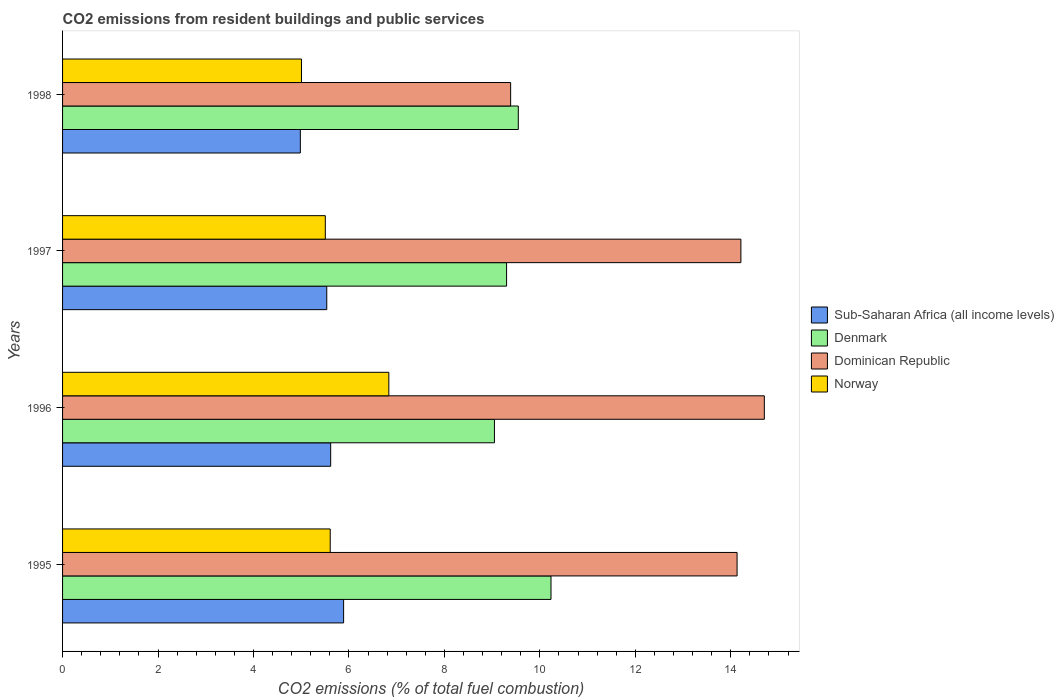How many bars are there on the 1st tick from the top?
Offer a terse response. 4. What is the label of the 4th group of bars from the top?
Keep it short and to the point. 1995. What is the total CO2 emitted in Dominican Republic in 1998?
Your response must be concise. 9.39. Across all years, what is the maximum total CO2 emitted in Dominican Republic?
Your answer should be very brief. 14.7. Across all years, what is the minimum total CO2 emitted in Dominican Republic?
Keep it short and to the point. 9.39. What is the total total CO2 emitted in Sub-Saharan Africa (all income levels) in the graph?
Your answer should be very brief. 22.02. What is the difference between the total CO2 emitted in Sub-Saharan Africa (all income levels) in 1996 and that in 1997?
Make the answer very short. 0.08. What is the difference between the total CO2 emitted in Dominican Republic in 1996 and the total CO2 emitted in Denmark in 1997?
Make the answer very short. 5.4. What is the average total CO2 emitted in Sub-Saharan Africa (all income levels) per year?
Ensure brevity in your answer.  5.51. In the year 1996, what is the difference between the total CO2 emitted in Sub-Saharan Africa (all income levels) and total CO2 emitted in Denmark?
Your answer should be compact. -3.43. What is the ratio of the total CO2 emitted in Sub-Saharan Africa (all income levels) in 1996 to that in 1998?
Keep it short and to the point. 1.13. What is the difference between the highest and the second highest total CO2 emitted in Dominican Republic?
Give a very brief answer. 0.49. What is the difference between the highest and the lowest total CO2 emitted in Dominican Republic?
Your answer should be compact. 5.32. In how many years, is the total CO2 emitted in Norway greater than the average total CO2 emitted in Norway taken over all years?
Your response must be concise. 1. Is the sum of the total CO2 emitted in Dominican Republic in 1995 and 1998 greater than the maximum total CO2 emitted in Denmark across all years?
Make the answer very short. Yes. Is it the case that in every year, the sum of the total CO2 emitted in Dominican Republic and total CO2 emitted in Sub-Saharan Africa (all income levels) is greater than the sum of total CO2 emitted in Norway and total CO2 emitted in Denmark?
Provide a succinct answer. No. What does the 2nd bar from the top in 1997 represents?
Offer a terse response. Dominican Republic. What does the 3rd bar from the bottom in 1997 represents?
Ensure brevity in your answer.  Dominican Republic. How many bars are there?
Offer a terse response. 16. How many years are there in the graph?
Ensure brevity in your answer.  4. Does the graph contain any zero values?
Your response must be concise. No. How many legend labels are there?
Provide a short and direct response. 4. How are the legend labels stacked?
Offer a terse response. Vertical. What is the title of the graph?
Offer a very short reply. CO2 emissions from resident buildings and public services. What is the label or title of the X-axis?
Give a very brief answer. CO2 emissions (% of total fuel combustion). What is the CO2 emissions (% of total fuel combustion) of Sub-Saharan Africa (all income levels) in 1995?
Ensure brevity in your answer.  5.89. What is the CO2 emissions (% of total fuel combustion) in Denmark in 1995?
Provide a succinct answer. 10.23. What is the CO2 emissions (% of total fuel combustion) in Dominican Republic in 1995?
Give a very brief answer. 14.13. What is the CO2 emissions (% of total fuel combustion) in Norway in 1995?
Make the answer very short. 5.61. What is the CO2 emissions (% of total fuel combustion) of Sub-Saharan Africa (all income levels) in 1996?
Offer a terse response. 5.62. What is the CO2 emissions (% of total fuel combustion) of Denmark in 1996?
Your answer should be very brief. 9.05. What is the CO2 emissions (% of total fuel combustion) in Dominican Republic in 1996?
Keep it short and to the point. 14.7. What is the CO2 emissions (% of total fuel combustion) of Norway in 1996?
Your answer should be very brief. 6.84. What is the CO2 emissions (% of total fuel combustion) in Sub-Saharan Africa (all income levels) in 1997?
Provide a short and direct response. 5.54. What is the CO2 emissions (% of total fuel combustion) of Denmark in 1997?
Provide a short and direct response. 9.3. What is the CO2 emissions (% of total fuel combustion) in Dominican Republic in 1997?
Provide a short and direct response. 14.21. What is the CO2 emissions (% of total fuel combustion) of Norway in 1997?
Provide a short and direct response. 5.51. What is the CO2 emissions (% of total fuel combustion) in Sub-Saharan Africa (all income levels) in 1998?
Ensure brevity in your answer.  4.98. What is the CO2 emissions (% of total fuel combustion) of Denmark in 1998?
Provide a succinct answer. 9.55. What is the CO2 emissions (% of total fuel combustion) of Dominican Republic in 1998?
Your answer should be very brief. 9.39. What is the CO2 emissions (% of total fuel combustion) in Norway in 1998?
Keep it short and to the point. 5.01. Across all years, what is the maximum CO2 emissions (% of total fuel combustion) of Sub-Saharan Africa (all income levels)?
Offer a terse response. 5.89. Across all years, what is the maximum CO2 emissions (% of total fuel combustion) in Denmark?
Ensure brevity in your answer.  10.23. Across all years, what is the maximum CO2 emissions (% of total fuel combustion) of Dominican Republic?
Provide a short and direct response. 14.7. Across all years, what is the maximum CO2 emissions (% of total fuel combustion) of Norway?
Keep it short and to the point. 6.84. Across all years, what is the minimum CO2 emissions (% of total fuel combustion) of Sub-Saharan Africa (all income levels)?
Give a very brief answer. 4.98. Across all years, what is the minimum CO2 emissions (% of total fuel combustion) of Denmark?
Give a very brief answer. 9.05. Across all years, what is the minimum CO2 emissions (% of total fuel combustion) of Dominican Republic?
Your response must be concise. 9.39. Across all years, what is the minimum CO2 emissions (% of total fuel combustion) of Norway?
Your response must be concise. 5.01. What is the total CO2 emissions (% of total fuel combustion) of Sub-Saharan Africa (all income levels) in the graph?
Keep it short and to the point. 22.02. What is the total CO2 emissions (% of total fuel combustion) of Denmark in the graph?
Provide a short and direct response. 38.13. What is the total CO2 emissions (% of total fuel combustion) of Dominican Republic in the graph?
Make the answer very short. 52.44. What is the total CO2 emissions (% of total fuel combustion) in Norway in the graph?
Offer a terse response. 22.95. What is the difference between the CO2 emissions (% of total fuel combustion) of Sub-Saharan Africa (all income levels) in 1995 and that in 1996?
Give a very brief answer. 0.27. What is the difference between the CO2 emissions (% of total fuel combustion) of Denmark in 1995 and that in 1996?
Offer a very short reply. 1.19. What is the difference between the CO2 emissions (% of total fuel combustion) of Dominican Republic in 1995 and that in 1996?
Offer a very short reply. -0.57. What is the difference between the CO2 emissions (% of total fuel combustion) in Norway in 1995 and that in 1996?
Ensure brevity in your answer.  -1.23. What is the difference between the CO2 emissions (% of total fuel combustion) of Sub-Saharan Africa (all income levels) in 1995 and that in 1997?
Give a very brief answer. 0.35. What is the difference between the CO2 emissions (% of total fuel combustion) in Denmark in 1995 and that in 1997?
Provide a short and direct response. 0.93. What is the difference between the CO2 emissions (% of total fuel combustion) in Dominican Republic in 1995 and that in 1997?
Provide a short and direct response. -0.08. What is the difference between the CO2 emissions (% of total fuel combustion) of Norway in 1995 and that in 1997?
Your answer should be compact. 0.1. What is the difference between the CO2 emissions (% of total fuel combustion) of Sub-Saharan Africa (all income levels) in 1995 and that in 1998?
Offer a very short reply. 0.91. What is the difference between the CO2 emissions (% of total fuel combustion) in Denmark in 1995 and that in 1998?
Your answer should be compact. 0.69. What is the difference between the CO2 emissions (% of total fuel combustion) of Dominican Republic in 1995 and that in 1998?
Offer a terse response. 4.74. What is the difference between the CO2 emissions (% of total fuel combustion) of Norway in 1995 and that in 1998?
Provide a succinct answer. 0.6. What is the difference between the CO2 emissions (% of total fuel combustion) in Sub-Saharan Africa (all income levels) in 1996 and that in 1997?
Offer a terse response. 0.08. What is the difference between the CO2 emissions (% of total fuel combustion) in Denmark in 1996 and that in 1997?
Keep it short and to the point. -0.25. What is the difference between the CO2 emissions (% of total fuel combustion) in Dominican Republic in 1996 and that in 1997?
Your answer should be very brief. 0.49. What is the difference between the CO2 emissions (% of total fuel combustion) in Norway in 1996 and that in 1997?
Your answer should be very brief. 1.33. What is the difference between the CO2 emissions (% of total fuel combustion) in Sub-Saharan Africa (all income levels) in 1996 and that in 1998?
Make the answer very short. 0.64. What is the difference between the CO2 emissions (% of total fuel combustion) in Denmark in 1996 and that in 1998?
Offer a very short reply. -0.5. What is the difference between the CO2 emissions (% of total fuel combustion) in Dominican Republic in 1996 and that in 1998?
Ensure brevity in your answer.  5.32. What is the difference between the CO2 emissions (% of total fuel combustion) in Norway in 1996 and that in 1998?
Provide a short and direct response. 1.83. What is the difference between the CO2 emissions (% of total fuel combustion) in Sub-Saharan Africa (all income levels) in 1997 and that in 1998?
Offer a very short reply. 0.55. What is the difference between the CO2 emissions (% of total fuel combustion) in Denmark in 1997 and that in 1998?
Give a very brief answer. -0.25. What is the difference between the CO2 emissions (% of total fuel combustion) of Dominican Republic in 1997 and that in 1998?
Provide a succinct answer. 4.82. What is the difference between the CO2 emissions (% of total fuel combustion) in Norway in 1997 and that in 1998?
Your answer should be very brief. 0.5. What is the difference between the CO2 emissions (% of total fuel combustion) in Sub-Saharan Africa (all income levels) in 1995 and the CO2 emissions (% of total fuel combustion) in Denmark in 1996?
Keep it short and to the point. -3.16. What is the difference between the CO2 emissions (% of total fuel combustion) of Sub-Saharan Africa (all income levels) in 1995 and the CO2 emissions (% of total fuel combustion) of Dominican Republic in 1996?
Provide a succinct answer. -8.81. What is the difference between the CO2 emissions (% of total fuel combustion) of Sub-Saharan Africa (all income levels) in 1995 and the CO2 emissions (% of total fuel combustion) of Norway in 1996?
Offer a terse response. -0.95. What is the difference between the CO2 emissions (% of total fuel combustion) of Denmark in 1995 and the CO2 emissions (% of total fuel combustion) of Dominican Republic in 1996?
Offer a very short reply. -4.47. What is the difference between the CO2 emissions (% of total fuel combustion) in Denmark in 1995 and the CO2 emissions (% of total fuel combustion) in Norway in 1996?
Your response must be concise. 3.4. What is the difference between the CO2 emissions (% of total fuel combustion) in Dominican Republic in 1995 and the CO2 emissions (% of total fuel combustion) in Norway in 1996?
Your response must be concise. 7.3. What is the difference between the CO2 emissions (% of total fuel combustion) of Sub-Saharan Africa (all income levels) in 1995 and the CO2 emissions (% of total fuel combustion) of Denmark in 1997?
Provide a short and direct response. -3.41. What is the difference between the CO2 emissions (% of total fuel combustion) of Sub-Saharan Africa (all income levels) in 1995 and the CO2 emissions (% of total fuel combustion) of Dominican Republic in 1997?
Make the answer very short. -8.32. What is the difference between the CO2 emissions (% of total fuel combustion) of Sub-Saharan Africa (all income levels) in 1995 and the CO2 emissions (% of total fuel combustion) of Norway in 1997?
Provide a short and direct response. 0.38. What is the difference between the CO2 emissions (% of total fuel combustion) of Denmark in 1995 and the CO2 emissions (% of total fuel combustion) of Dominican Republic in 1997?
Offer a very short reply. -3.98. What is the difference between the CO2 emissions (% of total fuel combustion) of Denmark in 1995 and the CO2 emissions (% of total fuel combustion) of Norway in 1997?
Ensure brevity in your answer.  4.73. What is the difference between the CO2 emissions (% of total fuel combustion) of Dominican Republic in 1995 and the CO2 emissions (% of total fuel combustion) of Norway in 1997?
Offer a terse response. 8.63. What is the difference between the CO2 emissions (% of total fuel combustion) of Sub-Saharan Africa (all income levels) in 1995 and the CO2 emissions (% of total fuel combustion) of Denmark in 1998?
Offer a very short reply. -3.66. What is the difference between the CO2 emissions (% of total fuel combustion) in Sub-Saharan Africa (all income levels) in 1995 and the CO2 emissions (% of total fuel combustion) in Dominican Republic in 1998?
Your answer should be compact. -3.5. What is the difference between the CO2 emissions (% of total fuel combustion) of Sub-Saharan Africa (all income levels) in 1995 and the CO2 emissions (% of total fuel combustion) of Norway in 1998?
Your response must be concise. 0.88. What is the difference between the CO2 emissions (% of total fuel combustion) in Denmark in 1995 and the CO2 emissions (% of total fuel combustion) in Dominican Republic in 1998?
Ensure brevity in your answer.  0.85. What is the difference between the CO2 emissions (% of total fuel combustion) of Denmark in 1995 and the CO2 emissions (% of total fuel combustion) of Norway in 1998?
Keep it short and to the point. 5.23. What is the difference between the CO2 emissions (% of total fuel combustion) in Dominican Republic in 1995 and the CO2 emissions (% of total fuel combustion) in Norway in 1998?
Provide a short and direct response. 9.13. What is the difference between the CO2 emissions (% of total fuel combustion) of Sub-Saharan Africa (all income levels) in 1996 and the CO2 emissions (% of total fuel combustion) of Denmark in 1997?
Ensure brevity in your answer.  -3.69. What is the difference between the CO2 emissions (% of total fuel combustion) of Sub-Saharan Africa (all income levels) in 1996 and the CO2 emissions (% of total fuel combustion) of Dominican Republic in 1997?
Provide a short and direct response. -8.6. What is the difference between the CO2 emissions (% of total fuel combustion) of Sub-Saharan Africa (all income levels) in 1996 and the CO2 emissions (% of total fuel combustion) of Norway in 1997?
Keep it short and to the point. 0.11. What is the difference between the CO2 emissions (% of total fuel combustion) of Denmark in 1996 and the CO2 emissions (% of total fuel combustion) of Dominican Republic in 1997?
Give a very brief answer. -5.16. What is the difference between the CO2 emissions (% of total fuel combustion) of Denmark in 1996 and the CO2 emissions (% of total fuel combustion) of Norway in 1997?
Provide a short and direct response. 3.54. What is the difference between the CO2 emissions (% of total fuel combustion) in Dominican Republic in 1996 and the CO2 emissions (% of total fuel combustion) in Norway in 1997?
Make the answer very short. 9.2. What is the difference between the CO2 emissions (% of total fuel combustion) of Sub-Saharan Africa (all income levels) in 1996 and the CO2 emissions (% of total fuel combustion) of Denmark in 1998?
Provide a succinct answer. -3.93. What is the difference between the CO2 emissions (% of total fuel combustion) in Sub-Saharan Africa (all income levels) in 1996 and the CO2 emissions (% of total fuel combustion) in Dominican Republic in 1998?
Your answer should be compact. -3.77. What is the difference between the CO2 emissions (% of total fuel combustion) in Sub-Saharan Africa (all income levels) in 1996 and the CO2 emissions (% of total fuel combustion) in Norway in 1998?
Your response must be concise. 0.61. What is the difference between the CO2 emissions (% of total fuel combustion) of Denmark in 1996 and the CO2 emissions (% of total fuel combustion) of Dominican Republic in 1998?
Your answer should be very brief. -0.34. What is the difference between the CO2 emissions (% of total fuel combustion) of Denmark in 1996 and the CO2 emissions (% of total fuel combustion) of Norway in 1998?
Make the answer very short. 4.04. What is the difference between the CO2 emissions (% of total fuel combustion) in Dominican Republic in 1996 and the CO2 emissions (% of total fuel combustion) in Norway in 1998?
Provide a succinct answer. 9.7. What is the difference between the CO2 emissions (% of total fuel combustion) in Sub-Saharan Africa (all income levels) in 1997 and the CO2 emissions (% of total fuel combustion) in Denmark in 1998?
Provide a succinct answer. -4.01. What is the difference between the CO2 emissions (% of total fuel combustion) of Sub-Saharan Africa (all income levels) in 1997 and the CO2 emissions (% of total fuel combustion) of Dominican Republic in 1998?
Make the answer very short. -3.85. What is the difference between the CO2 emissions (% of total fuel combustion) in Sub-Saharan Africa (all income levels) in 1997 and the CO2 emissions (% of total fuel combustion) in Norway in 1998?
Offer a very short reply. 0.53. What is the difference between the CO2 emissions (% of total fuel combustion) in Denmark in 1997 and the CO2 emissions (% of total fuel combustion) in Dominican Republic in 1998?
Your response must be concise. -0.09. What is the difference between the CO2 emissions (% of total fuel combustion) of Denmark in 1997 and the CO2 emissions (% of total fuel combustion) of Norway in 1998?
Offer a terse response. 4.3. What is the difference between the CO2 emissions (% of total fuel combustion) in Dominican Republic in 1997 and the CO2 emissions (% of total fuel combustion) in Norway in 1998?
Keep it short and to the point. 9.21. What is the average CO2 emissions (% of total fuel combustion) in Sub-Saharan Africa (all income levels) per year?
Provide a succinct answer. 5.51. What is the average CO2 emissions (% of total fuel combustion) in Denmark per year?
Your response must be concise. 9.53. What is the average CO2 emissions (% of total fuel combustion) of Dominican Republic per year?
Offer a terse response. 13.11. What is the average CO2 emissions (% of total fuel combustion) in Norway per year?
Keep it short and to the point. 5.74. In the year 1995, what is the difference between the CO2 emissions (% of total fuel combustion) in Sub-Saharan Africa (all income levels) and CO2 emissions (% of total fuel combustion) in Denmark?
Provide a short and direct response. -4.35. In the year 1995, what is the difference between the CO2 emissions (% of total fuel combustion) in Sub-Saharan Africa (all income levels) and CO2 emissions (% of total fuel combustion) in Dominican Republic?
Your answer should be very brief. -8.24. In the year 1995, what is the difference between the CO2 emissions (% of total fuel combustion) of Sub-Saharan Africa (all income levels) and CO2 emissions (% of total fuel combustion) of Norway?
Give a very brief answer. 0.28. In the year 1995, what is the difference between the CO2 emissions (% of total fuel combustion) of Denmark and CO2 emissions (% of total fuel combustion) of Dominican Republic?
Your response must be concise. -3.9. In the year 1995, what is the difference between the CO2 emissions (% of total fuel combustion) of Denmark and CO2 emissions (% of total fuel combustion) of Norway?
Give a very brief answer. 4.63. In the year 1995, what is the difference between the CO2 emissions (% of total fuel combustion) in Dominican Republic and CO2 emissions (% of total fuel combustion) in Norway?
Your answer should be compact. 8.52. In the year 1996, what is the difference between the CO2 emissions (% of total fuel combustion) of Sub-Saharan Africa (all income levels) and CO2 emissions (% of total fuel combustion) of Denmark?
Give a very brief answer. -3.43. In the year 1996, what is the difference between the CO2 emissions (% of total fuel combustion) of Sub-Saharan Africa (all income levels) and CO2 emissions (% of total fuel combustion) of Dominican Republic?
Offer a very short reply. -9.09. In the year 1996, what is the difference between the CO2 emissions (% of total fuel combustion) of Sub-Saharan Africa (all income levels) and CO2 emissions (% of total fuel combustion) of Norway?
Ensure brevity in your answer.  -1.22. In the year 1996, what is the difference between the CO2 emissions (% of total fuel combustion) of Denmark and CO2 emissions (% of total fuel combustion) of Dominican Republic?
Ensure brevity in your answer.  -5.65. In the year 1996, what is the difference between the CO2 emissions (% of total fuel combustion) of Denmark and CO2 emissions (% of total fuel combustion) of Norway?
Ensure brevity in your answer.  2.21. In the year 1996, what is the difference between the CO2 emissions (% of total fuel combustion) of Dominican Republic and CO2 emissions (% of total fuel combustion) of Norway?
Your answer should be very brief. 7.87. In the year 1997, what is the difference between the CO2 emissions (% of total fuel combustion) in Sub-Saharan Africa (all income levels) and CO2 emissions (% of total fuel combustion) in Denmark?
Provide a short and direct response. -3.77. In the year 1997, what is the difference between the CO2 emissions (% of total fuel combustion) in Sub-Saharan Africa (all income levels) and CO2 emissions (% of total fuel combustion) in Dominican Republic?
Keep it short and to the point. -8.68. In the year 1997, what is the difference between the CO2 emissions (% of total fuel combustion) of Sub-Saharan Africa (all income levels) and CO2 emissions (% of total fuel combustion) of Norway?
Keep it short and to the point. 0.03. In the year 1997, what is the difference between the CO2 emissions (% of total fuel combustion) in Denmark and CO2 emissions (% of total fuel combustion) in Dominican Republic?
Keep it short and to the point. -4.91. In the year 1997, what is the difference between the CO2 emissions (% of total fuel combustion) in Denmark and CO2 emissions (% of total fuel combustion) in Norway?
Make the answer very short. 3.8. In the year 1997, what is the difference between the CO2 emissions (% of total fuel combustion) in Dominican Republic and CO2 emissions (% of total fuel combustion) in Norway?
Make the answer very short. 8.71. In the year 1998, what is the difference between the CO2 emissions (% of total fuel combustion) in Sub-Saharan Africa (all income levels) and CO2 emissions (% of total fuel combustion) in Denmark?
Keep it short and to the point. -4.57. In the year 1998, what is the difference between the CO2 emissions (% of total fuel combustion) of Sub-Saharan Africa (all income levels) and CO2 emissions (% of total fuel combustion) of Dominican Republic?
Offer a very short reply. -4.41. In the year 1998, what is the difference between the CO2 emissions (% of total fuel combustion) in Sub-Saharan Africa (all income levels) and CO2 emissions (% of total fuel combustion) in Norway?
Offer a very short reply. -0.02. In the year 1998, what is the difference between the CO2 emissions (% of total fuel combustion) of Denmark and CO2 emissions (% of total fuel combustion) of Dominican Republic?
Offer a terse response. 0.16. In the year 1998, what is the difference between the CO2 emissions (% of total fuel combustion) of Denmark and CO2 emissions (% of total fuel combustion) of Norway?
Give a very brief answer. 4.54. In the year 1998, what is the difference between the CO2 emissions (% of total fuel combustion) of Dominican Republic and CO2 emissions (% of total fuel combustion) of Norway?
Ensure brevity in your answer.  4.38. What is the ratio of the CO2 emissions (% of total fuel combustion) of Sub-Saharan Africa (all income levels) in 1995 to that in 1996?
Keep it short and to the point. 1.05. What is the ratio of the CO2 emissions (% of total fuel combustion) of Denmark in 1995 to that in 1996?
Make the answer very short. 1.13. What is the ratio of the CO2 emissions (% of total fuel combustion) of Dominican Republic in 1995 to that in 1996?
Ensure brevity in your answer.  0.96. What is the ratio of the CO2 emissions (% of total fuel combustion) in Norway in 1995 to that in 1996?
Your answer should be very brief. 0.82. What is the ratio of the CO2 emissions (% of total fuel combustion) of Sub-Saharan Africa (all income levels) in 1995 to that in 1997?
Make the answer very short. 1.06. What is the ratio of the CO2 emissions (% of total fuel combustion) in Denmark in 1995 to that in 1997?
Your answer should be compact. 1.1. What is the ratio of the CO2 emissions (% of total fuel combustion) of Norway in 1995 to that in 1997?
Provide a succinct answer. 1.02. What is the ratio of the CO2 emissions (% of total fuel combustion) of Sub-Saharan Africa (all income levels) in 1995 to that in 1998?
Provide a short and direct response. 1.18. What is the ratio of the CO2 emissions (% of total fuel combustion) of Denmark in 1995 to that in 1998?
Your answer should be compact. 1.07. What is the ratio of the CO2 emissions (% of total fuel combustion) in Dominican Republic in 1995 to that in 1998?
Give a very brief answer. 1.51. What is the ratio of the CO2 emissions (% of total fuel combustion) in Norway in 1995 to that in 1998?
Offer a very short reply. 1.12. What is the ratio of the CO2 emissions (% of total fuel combustion) of Sub-Saharan Africa (all income levels) in 1996 to that in 1997?
Your answer should be compact. 1.01. What is the ratio of the CO2 emissions (% of total fuel combustion) in Denmark in 1996 to that in 1997?
Your answer should be compact. 0.97. What is the ratio of the CO2 emissions (% of total fuel combustion) in Dominican Republic in 1996 to that in 1997?
Offer a terse response. 1.03. What is the ratio of the CO2 emissions (% of total fuel combustion) in Norway in 1996 to that in 1997?
Your answer should be very brief. 1.24. What is the ratio of the CO2 emissions (% of total fuel combustion) of Sub-Saharan Africa (all income levels) in 1996 to that in 1998?
Give a very brief answer. 1.13. What is the ratio of the CO2 emissions (% of total fuel combustion) in Denmark in 1996 to that in 1998?
Keep it short and to the point. 0.95. What is the ratio of the CO2 emissions (% of total fuel combustion) in Dominican Republic in 1996 to that in 1998?
Offer a very short reply. 1.57. What is the ratio of the CO2 emissions (% of total fuel combustion) of Norway in 1996 to that in 1998?
Offer a terse response. 1.37. What is the ratio of the CO2 emissions (% of total fuel combustion) of Sub-Saharan Africa (all income levels) in 1997 to that in 1998?
Make the answer very short. 1.11. What is the ratio of the CO2 emissions (% of total fuel combustion) of Denmark in 1997 to that in 1998?
Your answer should be compact. 0.97. What is the ratio of the CO2 emissions (% of total fuel combustion) in Dominican Republic in 1997 to that in 1998?
Give a very brief answer. 1.51. What is the ratio of the CO2 emissions (% of total fuel combustion) in Norway in 1997 to that in 1998?
Keep it short and to the point. 1.1. What is the difference between the highest and the second highest CO2 emissions (% of total fuel combustion) in Sub-Saharan Africa (all income levels)?
Offer a very short reply. 0.27. What is the difference between the highest and the second highest CO2 emissions (% of total fuel combustion) in Denmark?
Offer a very short reply. 0.69. What is the difference between the highest and the second highest CO2 emissions (% of total fuel combustion) of Dominican Republic?
Keep it short and to the point. 0.49. What is the difference between the highest and the second highest CO2 emissions (% of total fuel combustion) in Norway?
Your response must be concise. 1.23. What is the difference between the highest and the lowest CO2 emissions (% of total fuel combustion) in Sub-Saharan Africa (all income levels)?
Offer a terse response. 0.91. What is the difference between the highest and the lowest CO2 emissions (% of total fuel combustion) in Denmark?
Offer a very short reply. 1.19. What is the difference between the highest and the lowest CO2 emissions (% of total fuel combustion) of Dominican Republic?
Ensure brevity in your answer.  5.32. What is the difference between the highest and the lowest CO2 emissions (% of total fuel combustion) of Norway?
Keep it short and to the point. 1.83. 